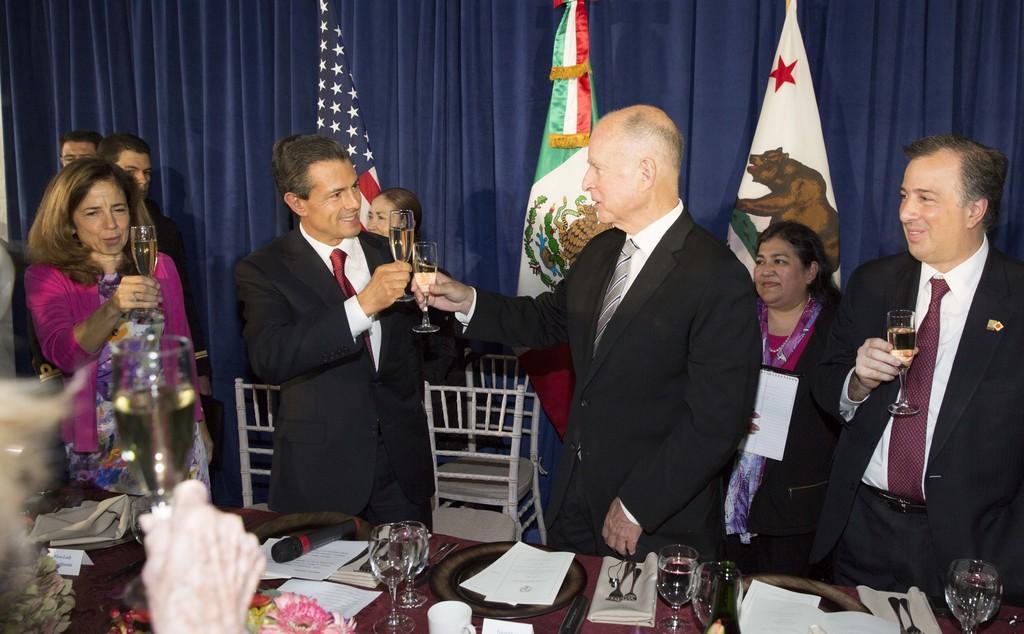Please provide a concise description of this image. In this image we can see people standing on the floor and some are holding beverage glasses in their hands. In the foreground we can see glass tumblers, napkins, mic, papers, flowers and cutlery. In the background we can see curtain and flags. 